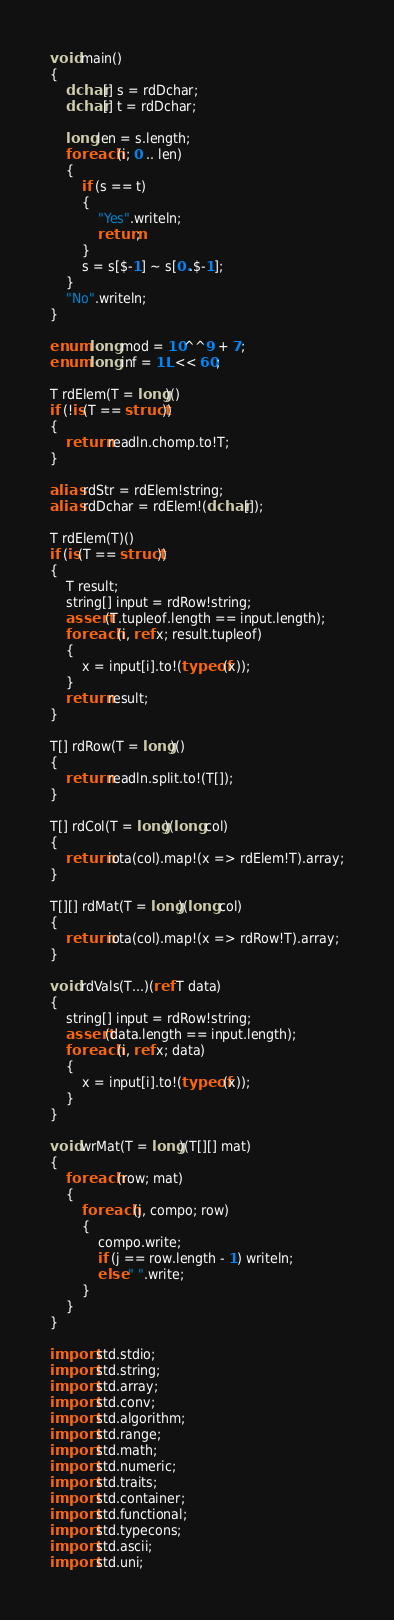Convert code to text. <code><loc_0><loc_0><loc_500><loc_500><_D_>void main()
{
    dchar[] s = rdDchar;
    dchar[] t = rdDchar;

    long len = s.length;
    foreach (i; 0 .. len)
    {
        if (s == t)
        {
            "Yes".writeln;
            return;
        }
        s = s[$-1] ~ s[0..$-1];
    }
    "No".writeln;
}

enum long mod = 10^^9 + 7;
enum long inf = 1L << 60;

T rdElem(T = long)()
if (!is(T == struct))
{
    return readln.chomp.to!T;
}

alias rdStr = rdElem!string;
alias rdDchar = rdElem!(dchar[]);

T rdElem(T)()
if (is(T == struct))
{
    T result;
    string[] input = rdRow!string;
    assert(T.tupleof.length == input.length);
    foreach (i, ref x; result.tupleof)
    {
        x = input[i].to!(typeof(x));
    }
    return result;
}

T[] rdRow(T = long)()
{
    return readln.split.to!(T[]);
}

T[] rdCol(T = long)(long col)
{
    return iota(col).map!(x => rdElem!T).array;
}

T[][] rdMat(T = long)(long col)
{
    return iota(col).map!(x => rdRow!T).array;
}

void rdVals(T...)(ref T data)
{
    string[] input = rdRow!string;
    assert(data.length == input.length);
    foreach (i, ref x; data)
    {
        x = input[i].to!(typeof(x));
    }
}

void wrMat(T = long)(T[][] mat)
{
    foreach (row; mat)
    {
        foreach (j, compo; row)
        {
            compo.write;
            if (j == row.length - 1) writeln;
            else " ".write;
        }
    }
}

import std.stdio;
import std.string;
import std.array;
import std.conv;
import std.algorithm;
import std.range;
import std.math;
import std.numeric;
import std.traits;
import std.container;
import std.functional;
import std.typecons;
import std.ascii;
import std.uni;</code> 